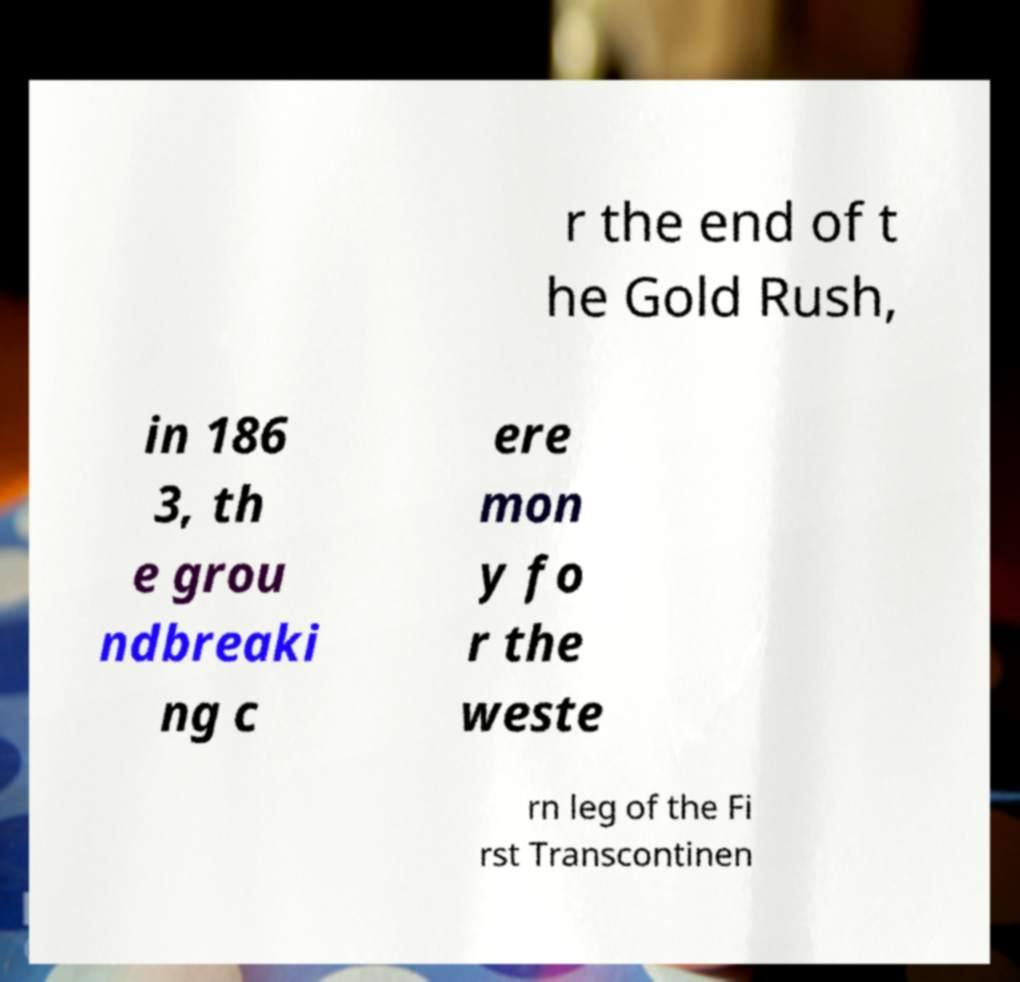Please read and relay the text visible in this image. What does it say? r the end of t he Gold Rush, in 186 3, th e grou ndbreaki ng c ere mon y fo r the weste rn leg of the Fi rst Transcontinen 